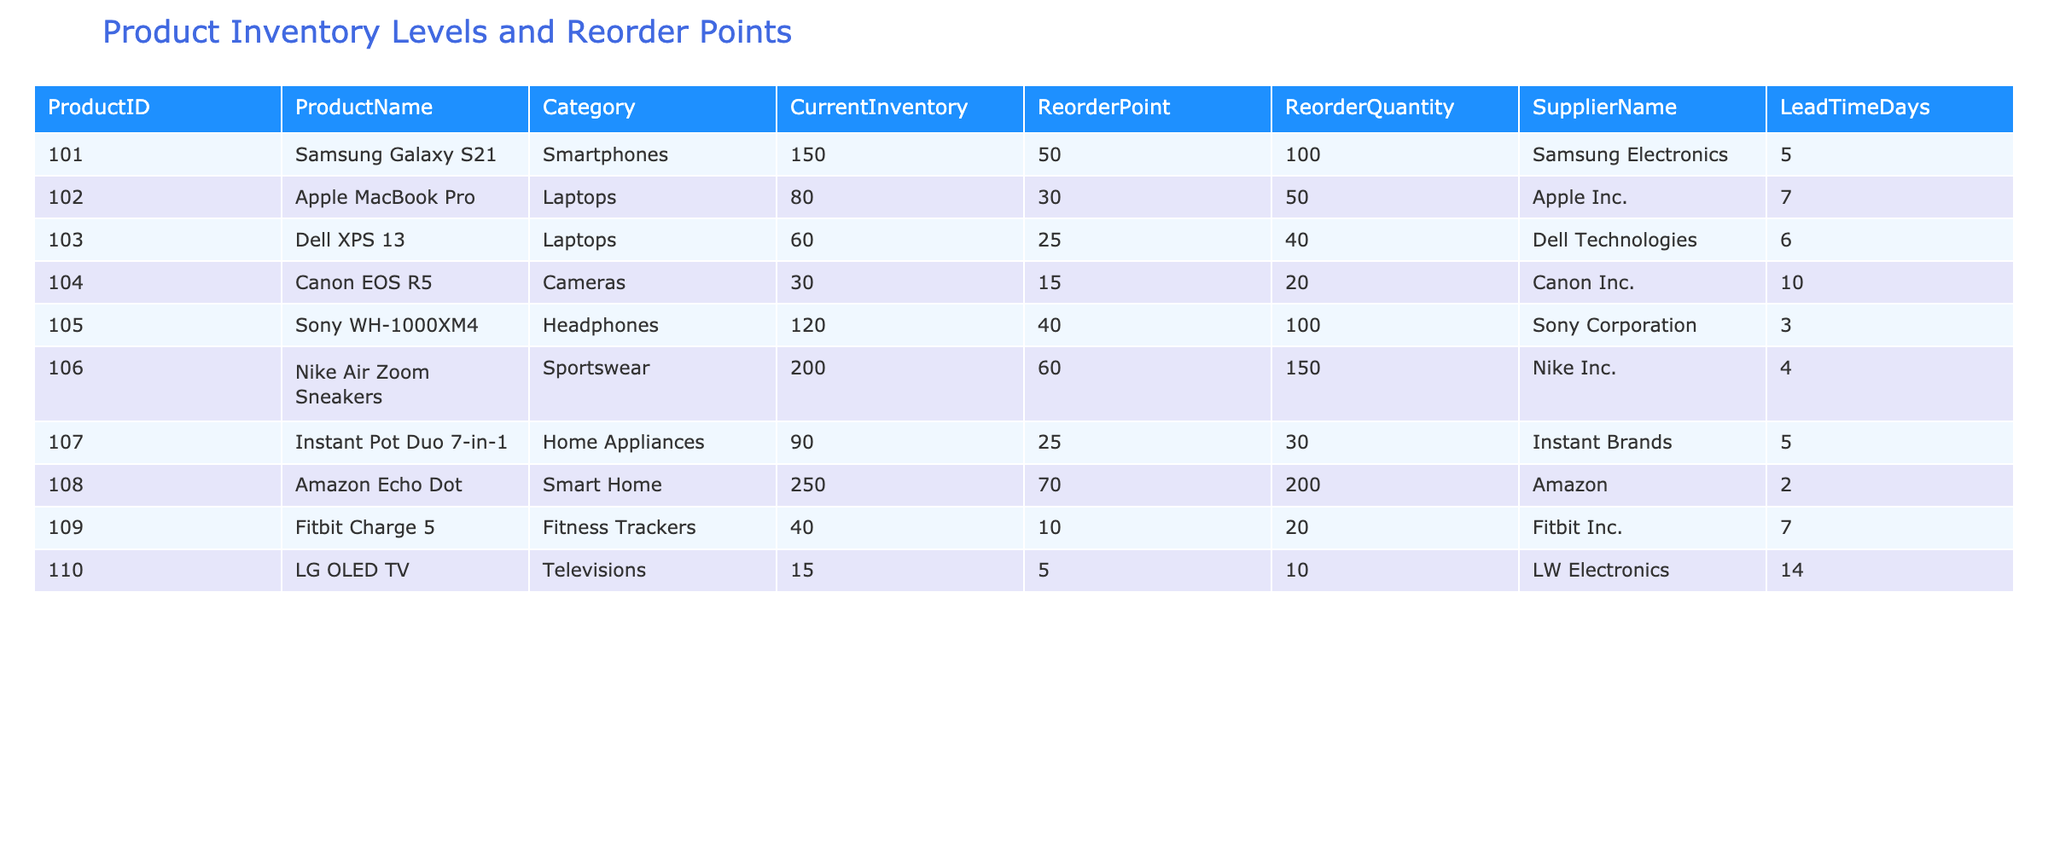What is the current inventory level of the Samsung Galaxy S21? The table lists the product "Samsung Galaxy S21" with the corresponding "CurrentInventory" value. Looking at the row for "Samsung Galaxy S21," the current inventory level is 150.
Answer: 150 What is the reorder quantity for the Apple MacBook Pro? In the table, for "Apple MacBook Pro", the column "ReorderQuantity" indicates how many units should be reordered. The value in that column is 50.
Answer: 50 Which product has the highest current inventory level? To find the product with the highest inventory, we compare the "CurrentInventory" values. The product "Amazon Echo Dot" has the highest inventory level at 250.
Answer: Amazon Echo Dot Is the reorder point for the LG OLED TV greater than or equal to 10? Checking the "ReorderPoint" for "LG OLED TV," it is 5. Since 5 is less than 10, the statement is false.
Answer: No What is the total current inventory for all sportswear products? The table shows only one sportswear product, "Nike Air Zoom Sneakers," with a "CurrentInventory" of 200. Therefore, the total current inventory for sportswear products is just this value.
Answer: 200 How many products have a reorder point lower than 20? We examine the table and find the products: "Canon EOS R5" (reorder point 15) and "Fitbit Charge 5" (reorder point 10) have reorder points lower than 20. Thus, there are 2 such products.
Answer: 2 What is the average current inventory of all products in the Cameras category? The table shows only one camera product, "Canon EOS R5," with a "CurrentInventory" of 30. Since there is only one entry, the average is simply 30 (30/1 = 30).
Answer: 30 If we add the current inventories of laptops and fitness trackers, what is the resulting total? The laptops have a current inventory of 80 (Apple MacBook Pro) + 60 (Dell XPS 13) = 140. The fitness tracker has a current inventory of 40 (Fitbit Charge 5). Adding these gives 140 + 40 = 180.
Answer: 180 Which supplier has the longest lead time, and what is that lead time? Reviewing the "LeadTimeDays" column, "LG OLED TV" from "LW Electronics" has the longest lead time of 14 days.
Answer: LW Electronics, 14 days 